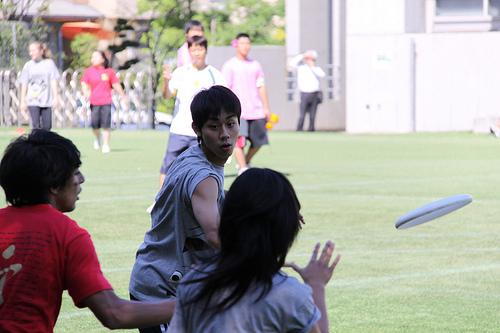State the main subject matter and its actions taking place within the picture. A white frisbee hovers in the air as a team of players, including one in red, plays frisbee on a field of green grass. Quickly outline the central figure and its corresponding action within the photo. A white frisbee soars in the air while multiple players enjoy a frisbee game on a field with green grass. Elucidate the primary object and the ongoing action occurring in the photograph. The picture showcases a white frisbee gliding through the sky, as a group of individuals partake in a frisbee match on a green field. Give a short explanation of the main subject and its behavior in the image. A white frisbee is caught mid-flight as several people, including one in red, play frisbee on a grass-covered field. In a concise manner, outline the central theme and related action portrayed in the image. The photo depicts a white frisbee in mid-flight, with several people participating in a frisbee game on a lush field. Provide a brief account of the primary topic and its engagement in the scene. A white frisbee can be seen flying, as a group of people, one wearing a red shirt, play frisbee on a grassy expanse. Provide a succinct description of the main subject and its activity displayed in the picture. In the image, a white frisbee flies through the air as multiple players engage in a frisbee game on a grassy area. Briefly mention the key elements and their involvement in the photo. A white frisbee is soaring through the air, while a group of people, including a man in a red shirt, play frisbee on a verdant field. Summarize the primary focal point and its action in the image. A flying white frisbee is being chased by three frisbee players on a grassy field. Illustrate the chief subject and its movement in the image. The image captures a white frisbee in motion, with several participants, one in a red shirt, playing frisbee on a green lawn. 